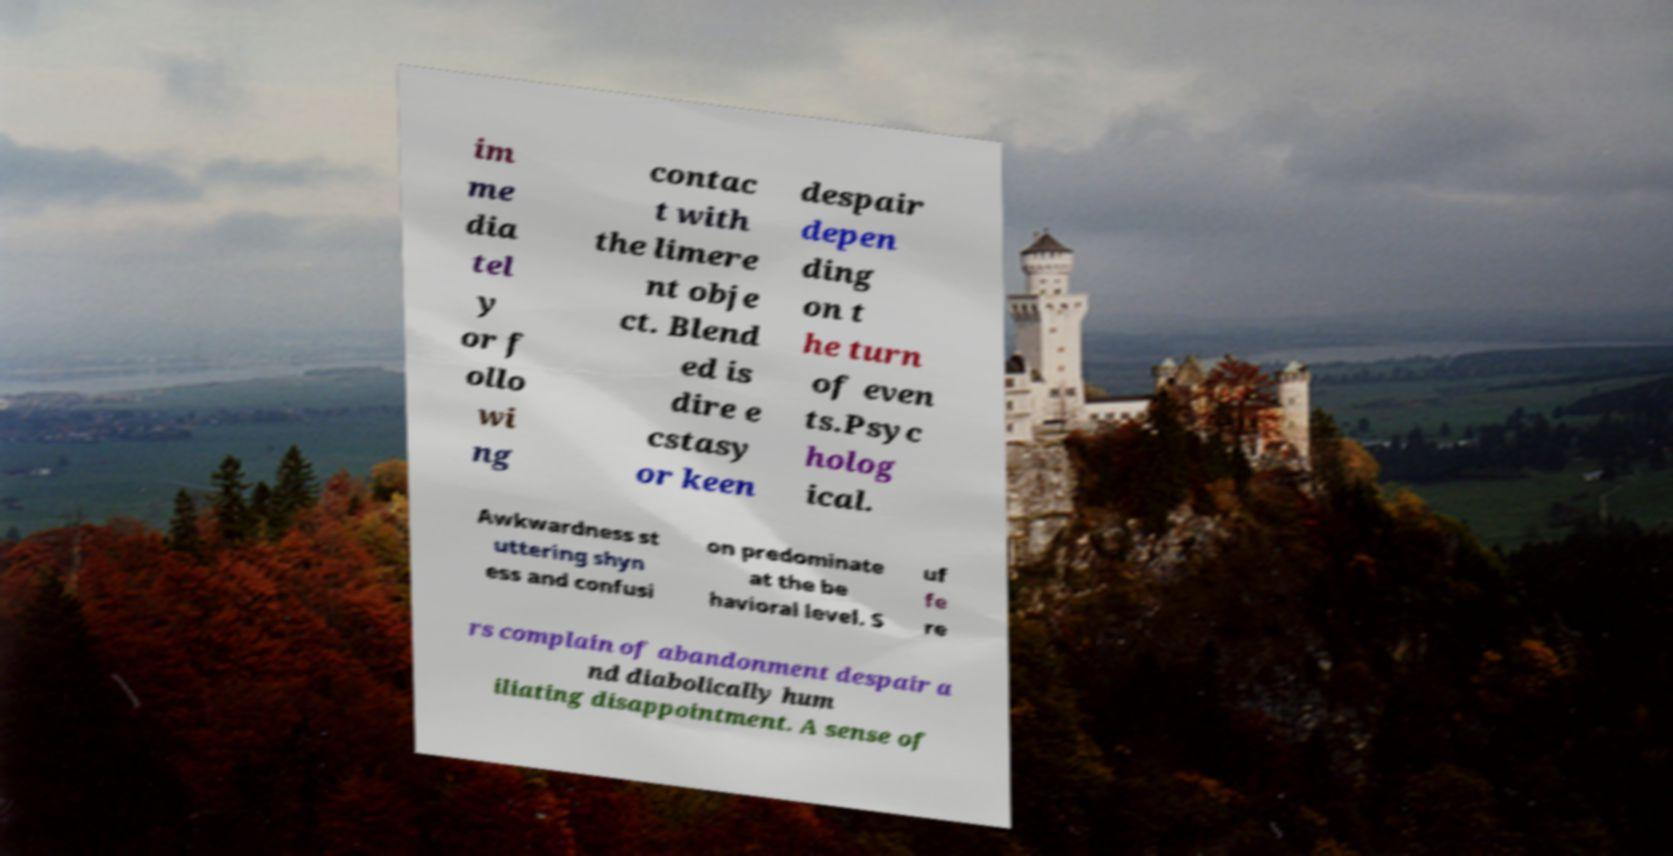For documentation purposes, I need the text within this image transcribed. Could you provide that? im me dia tel y or f ollo wi ng contac t with the limere nt obje ct. Blend ed is dire e cstasy or keen despair depen ding on t he turn of even ts.Psyc holog ical. Awkwardness st uttering shyn ess and confusi on predominate at the be havioral level. S uf fe re rs complain of abandonment despair a nd diabolically hum iliating disappointment. A sense of 